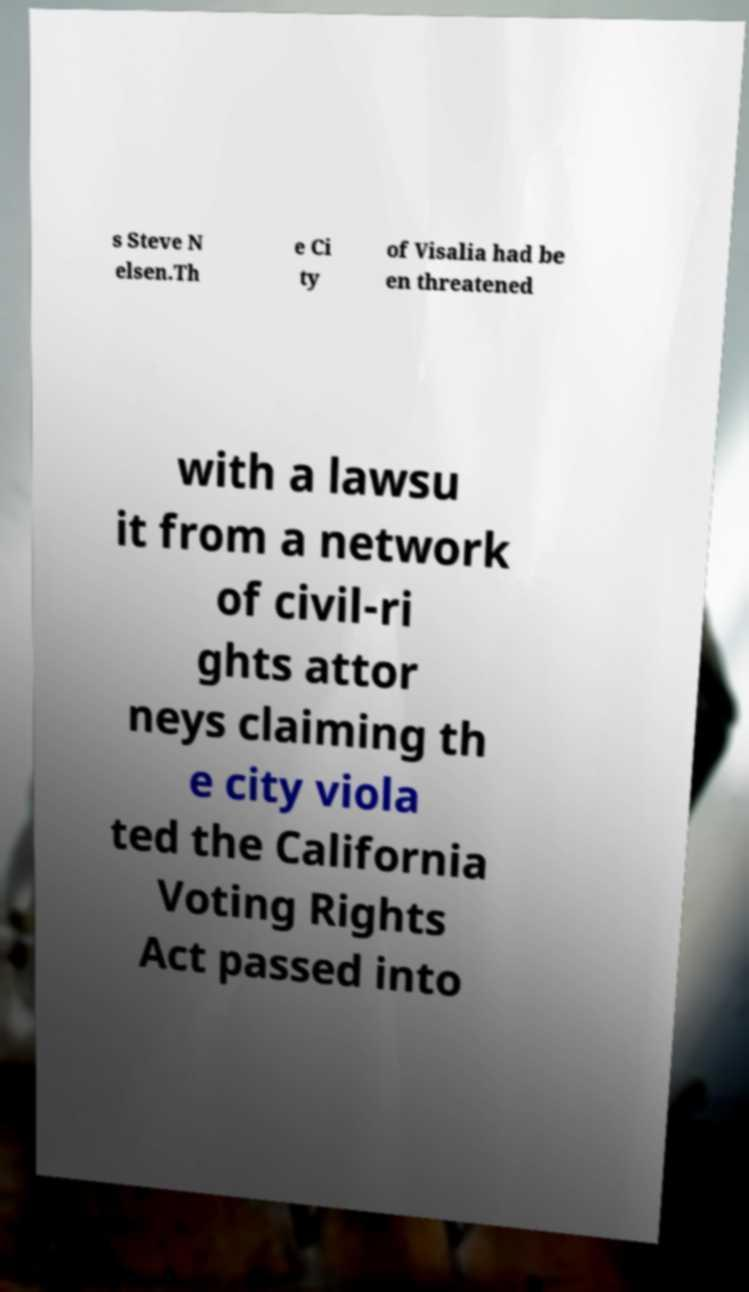Could you extract and type out the text from this image? s Steve N elsen.Th e Ci ty of Visalia had be en threatened with a lawsu it from a network of civil-ri ghts attor neys claiming th e city viola ted the California Voting Rights Act passed into 